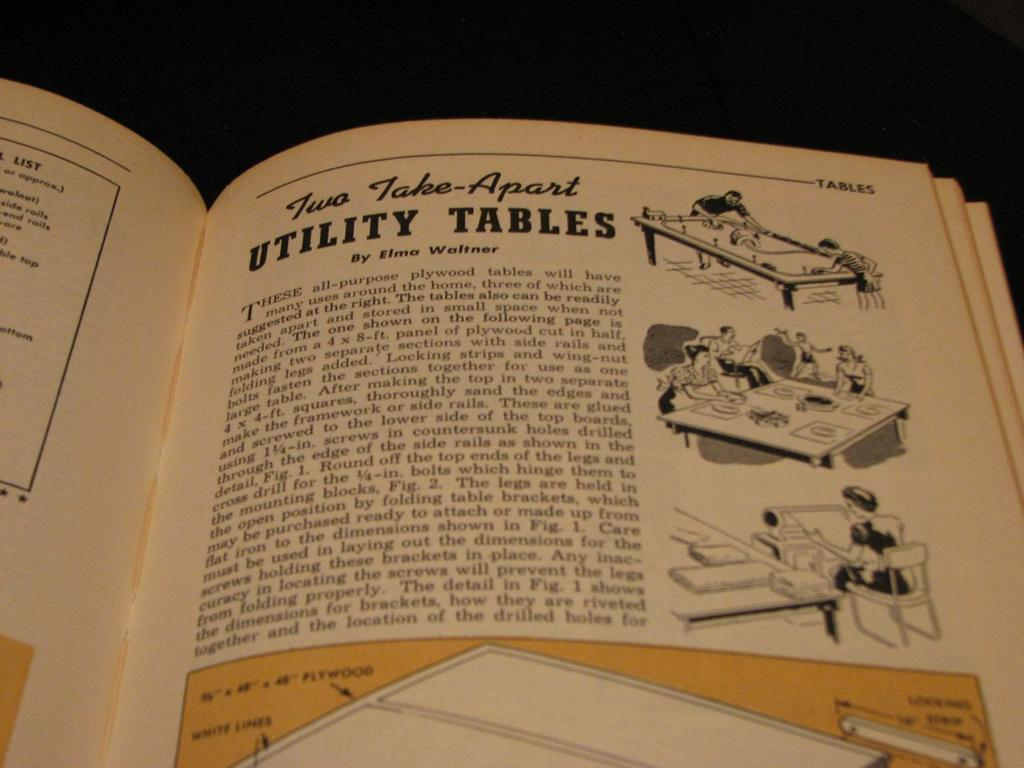<image>
Offer a succinct explanation of the picture presented. A book is open to a story by Elmo Waltner 